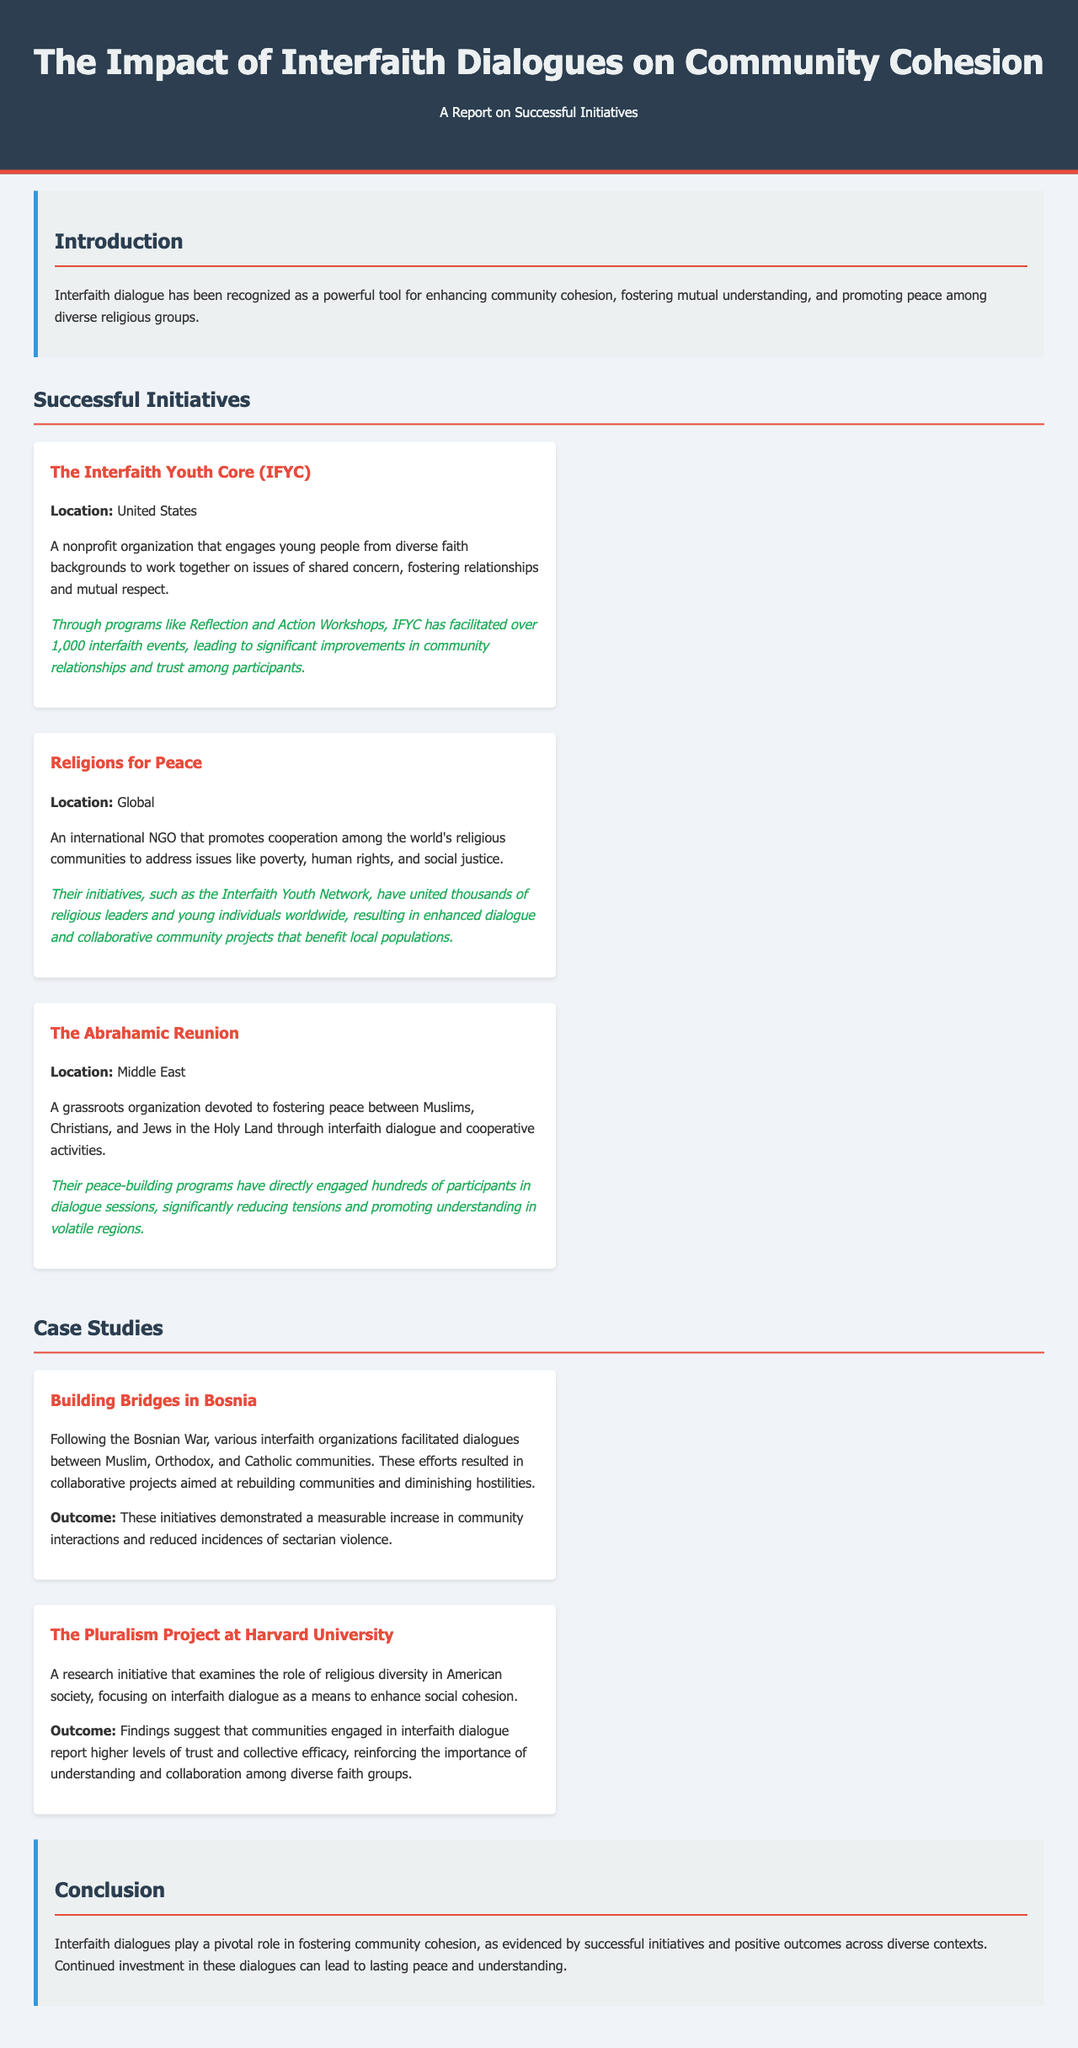What is the primary goal of interfaith dialogue? The primary goal of interfaith dialogue is to enhance community cohesion, foster mutual understanding, and promote peace among diverse religious groups.
Answer: to enhance community cohesion, foster mutual understanding, and promote peace Where is The Interfaith Youth Core based? The Interfaith Youth Core (IFYC) is located in the United States.
Answer: United States What type of organization is Religions for Peace? Religions for Peace is an international NGO.
Answer: international NGO What was a significant outcome of the Building Bridges in Bosnia initiative? A significant outcome was a measurable increase in community interactions and reduced incidences of sectarian violence.
Answer: measurable increase in community interactions and reduced incidences of sectarian violence How many interfaith events has IFYC facilitated? IFYC has facilitated over 1,000 interfaith events.
Answer: over 1,000 What does the Pluralism Project at Harvard University focus on? The Pluralism Project focuses on interfaith dialogue as a means to enhance social cohesion.
Answer: interfaith dialogue as a means to enhance social cohesion What is one impact of the Abrahamic Reunion's peace-building programs? One impact is significantly reducing tensions and promoting understanding in volatile regions.
Answer: significantly reducing tensions and promoting understanding Which community groups were involved in the Building Bridges in Bosnia initiative? The involved community groups were Muslim, Orthodox, and Catholic communities.
Answer: Muslim, Orthodox, and Catholic communities What does the conclusion emphasize about interfaith dialogues? The conclusion emphasizes that interfaith dialogues play a pivotal role in fostering community cohesion.
Answer: play a pivotal role in fostering community cohesion 